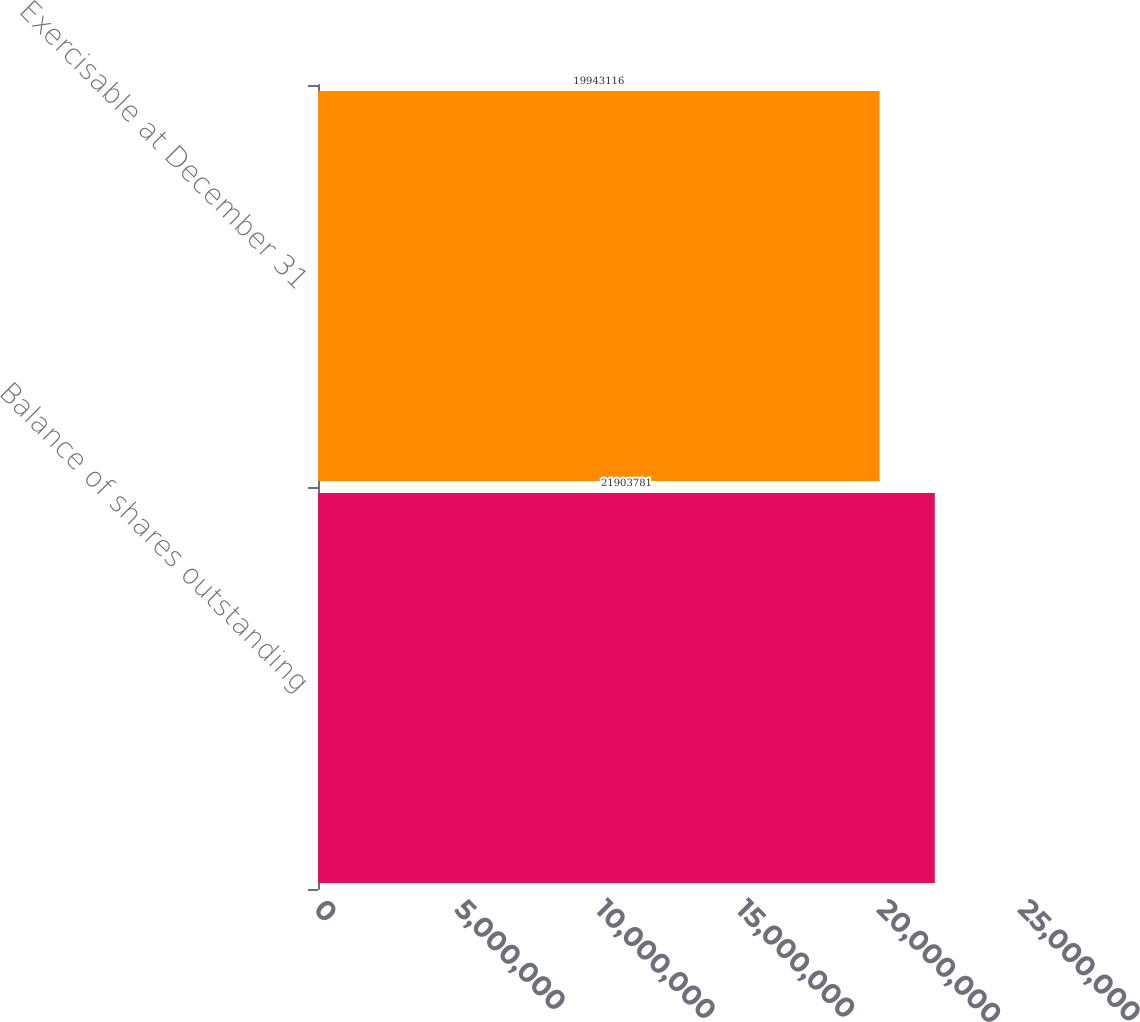Convert chart to OTSL. <chart><loc_0><loc_0><loc_500><loc_500><bar_chart><fcel>Balance of shares outstanding<fcel>Exercisable at December 31<nl><fcel>2.19038e+07<fcel>1.99431e+07<nl></chart> 